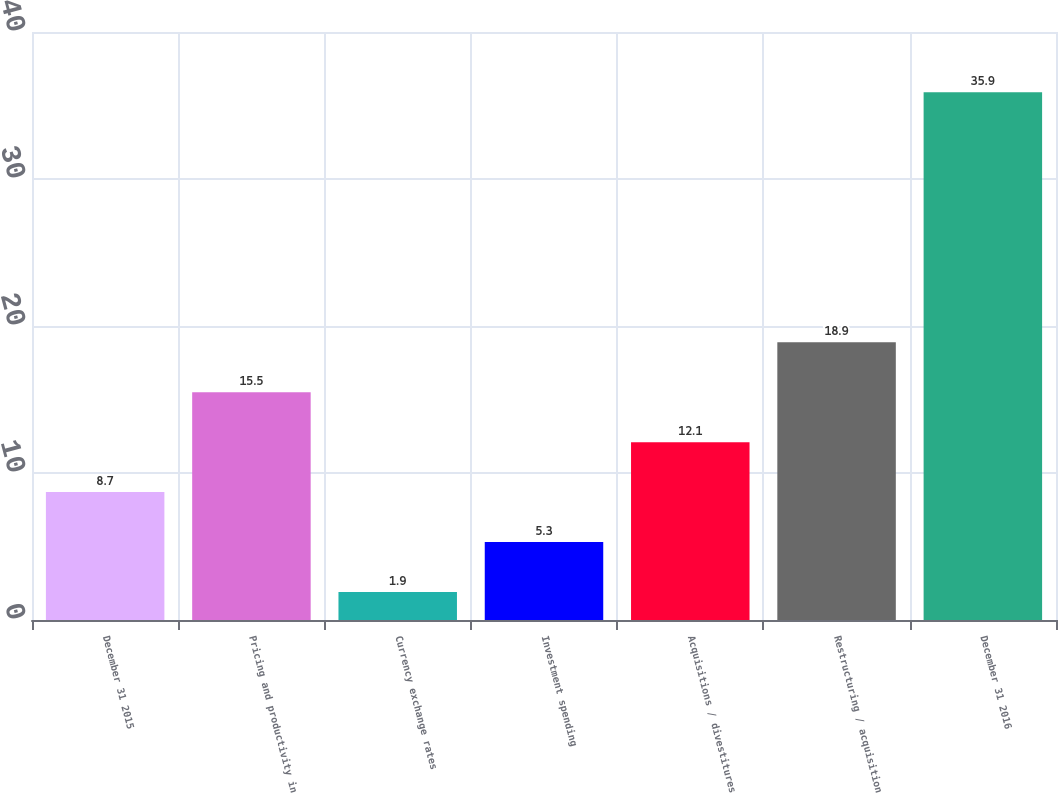<chart> <loc_0><loc_0><loc_500><loc_500><bar_chart><fcel>December 31 2015<fcel>Pricing and productivity in<fcel>Currency exchange rates<fcel>Investment spending<fcel>Acquisitions / divestitures<fcel>Restructuring / acquisition<fcel>December 31 2016<nl><fcel>8.7<fcel>15.5<fcel>1.9<fcel>5.3<fcel>12.1<fcel>18.9<fcel>35.9<nl></chart> 